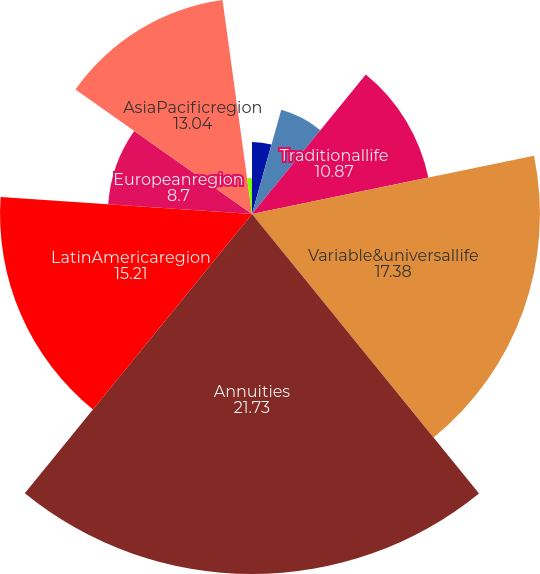<chart> <loc_0><loc_0><loc_500><loc_500><pie_chart><fcel>Grouplife<fcel>Retirement & savings<fcel>Subtotal<fcel>Traditionallife<fcel>Variable&universallife<fcel>Annuities<fcel>LatinAmericaregion<fcel>Europeanregion<fcel>AsiaPacificregion<fcel>Corporate&Other<nl><fcel>4.35%<fcel>0.01%<fcel>6.53%<fcel>10.87%<fcel>17.38%<fcel>21.73%<fcel>15.21%<fcel>8.7%<fcel>13.04%<fcel>2.18%<nl></chart> 